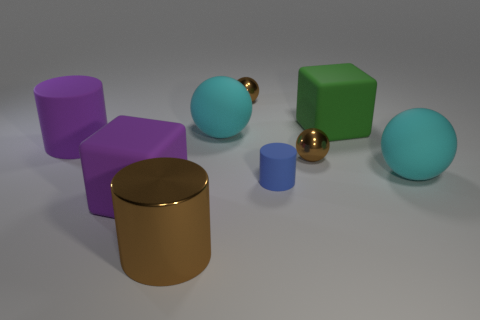How many objects are brown metallic objects that are on the right side of the big metal object or large matte spheres that are to the left of the green block?
Offer a terse response. 3. Are there fewer green matte blocks than small blocks?
Make the answer very short. No. What number of objects are metal cylinders or small cyan matte blocks?
Your answer should be very brief. 1. Is the shape of the large shiny object the same as the blue rubber object?
Make the answer very short. Yes. There is a rubber cylinder that is to the left of the big metallic thing; does it have the same size as the brown metal thing that is behind the large purple matte cylinder?
Your answer should be very brief. No. What material is the thing that is right of the purple matte cube and in front of the blue matte thing?
Keep it short and to the point. Metal. Is there anything else that has the same color as the metallic cylinder?
Provide a succinct answer. Yes. Are there fewer tiny spheres that are behind the green rubber object than green blocks?
Your response must be concise. No. Are there more small gray metal cylinders than rubber cylinders?
Make the answer very short. No. Are there any matte cubes that are in front of the cyan matte object to the right of the tiny metal thing in front of the purple matte cylinder?
Ensure brevity in your answer.  Yes. 